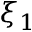Convert formula to latex. <formula><loc_0><loc_0><loc_500><loc_500>\xi _ { 1 }</formula> 